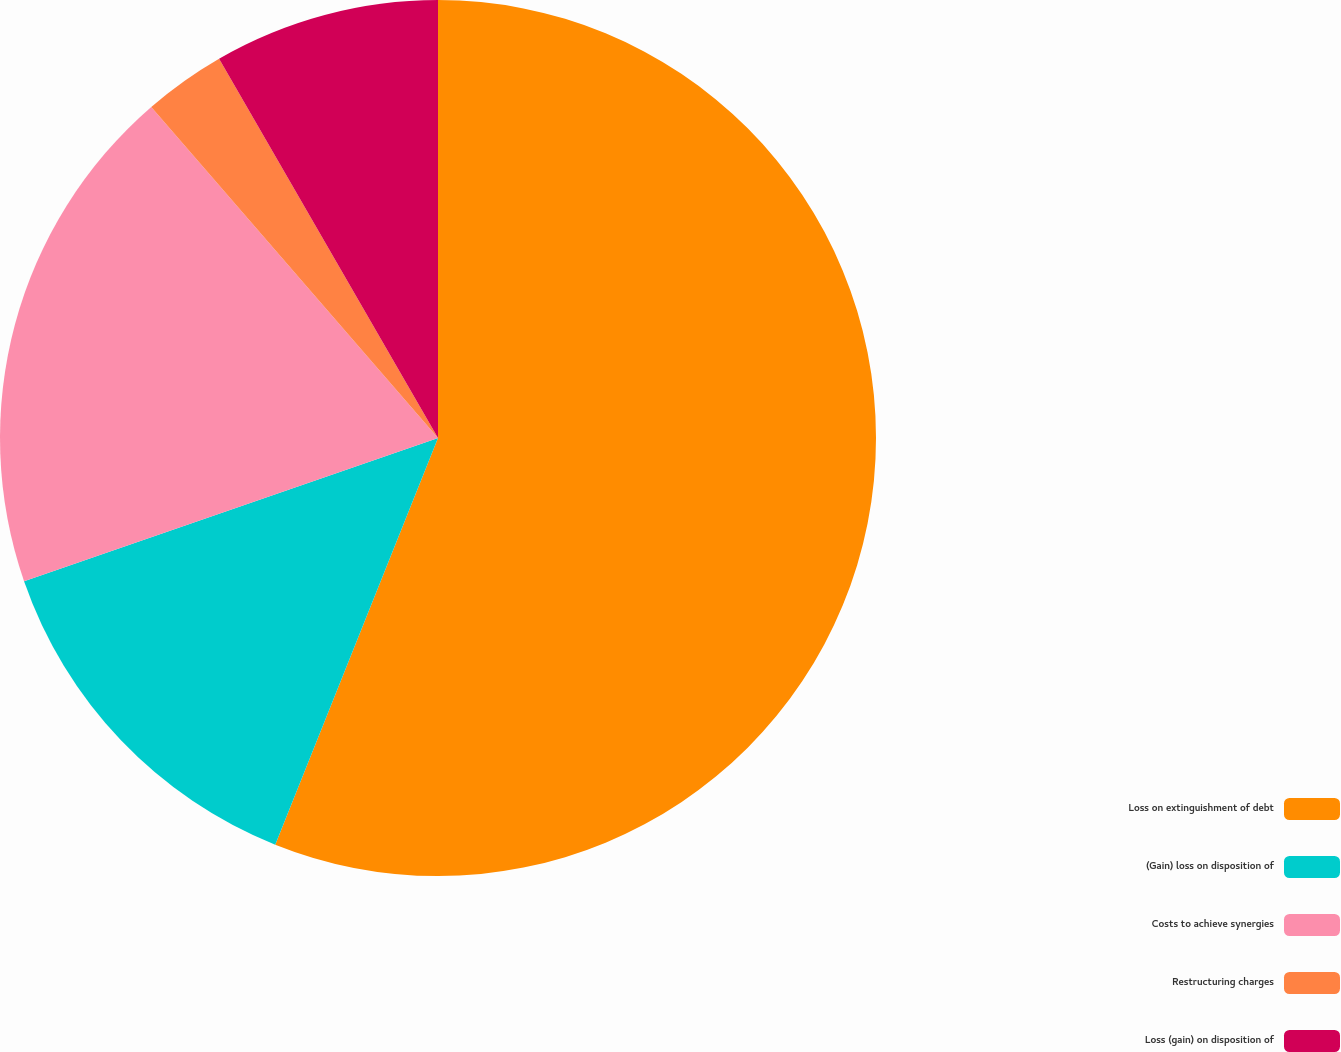Convert chart. <chart><loc_0><loc_0><loc_500><loc_500><pie_chart><fcel>Loss on extinguishment of debt<fcel>(Gain) loss on disposition of<fcel>Costs to achieve synergies<fcel>Restructuring charges<fcel>Loss (gain) on disposition of<nl><fcel>56.06%<fcel>13.64%<fcel>18.94%<fcel>3.03%<fcel>8.33%<nl></chart> 